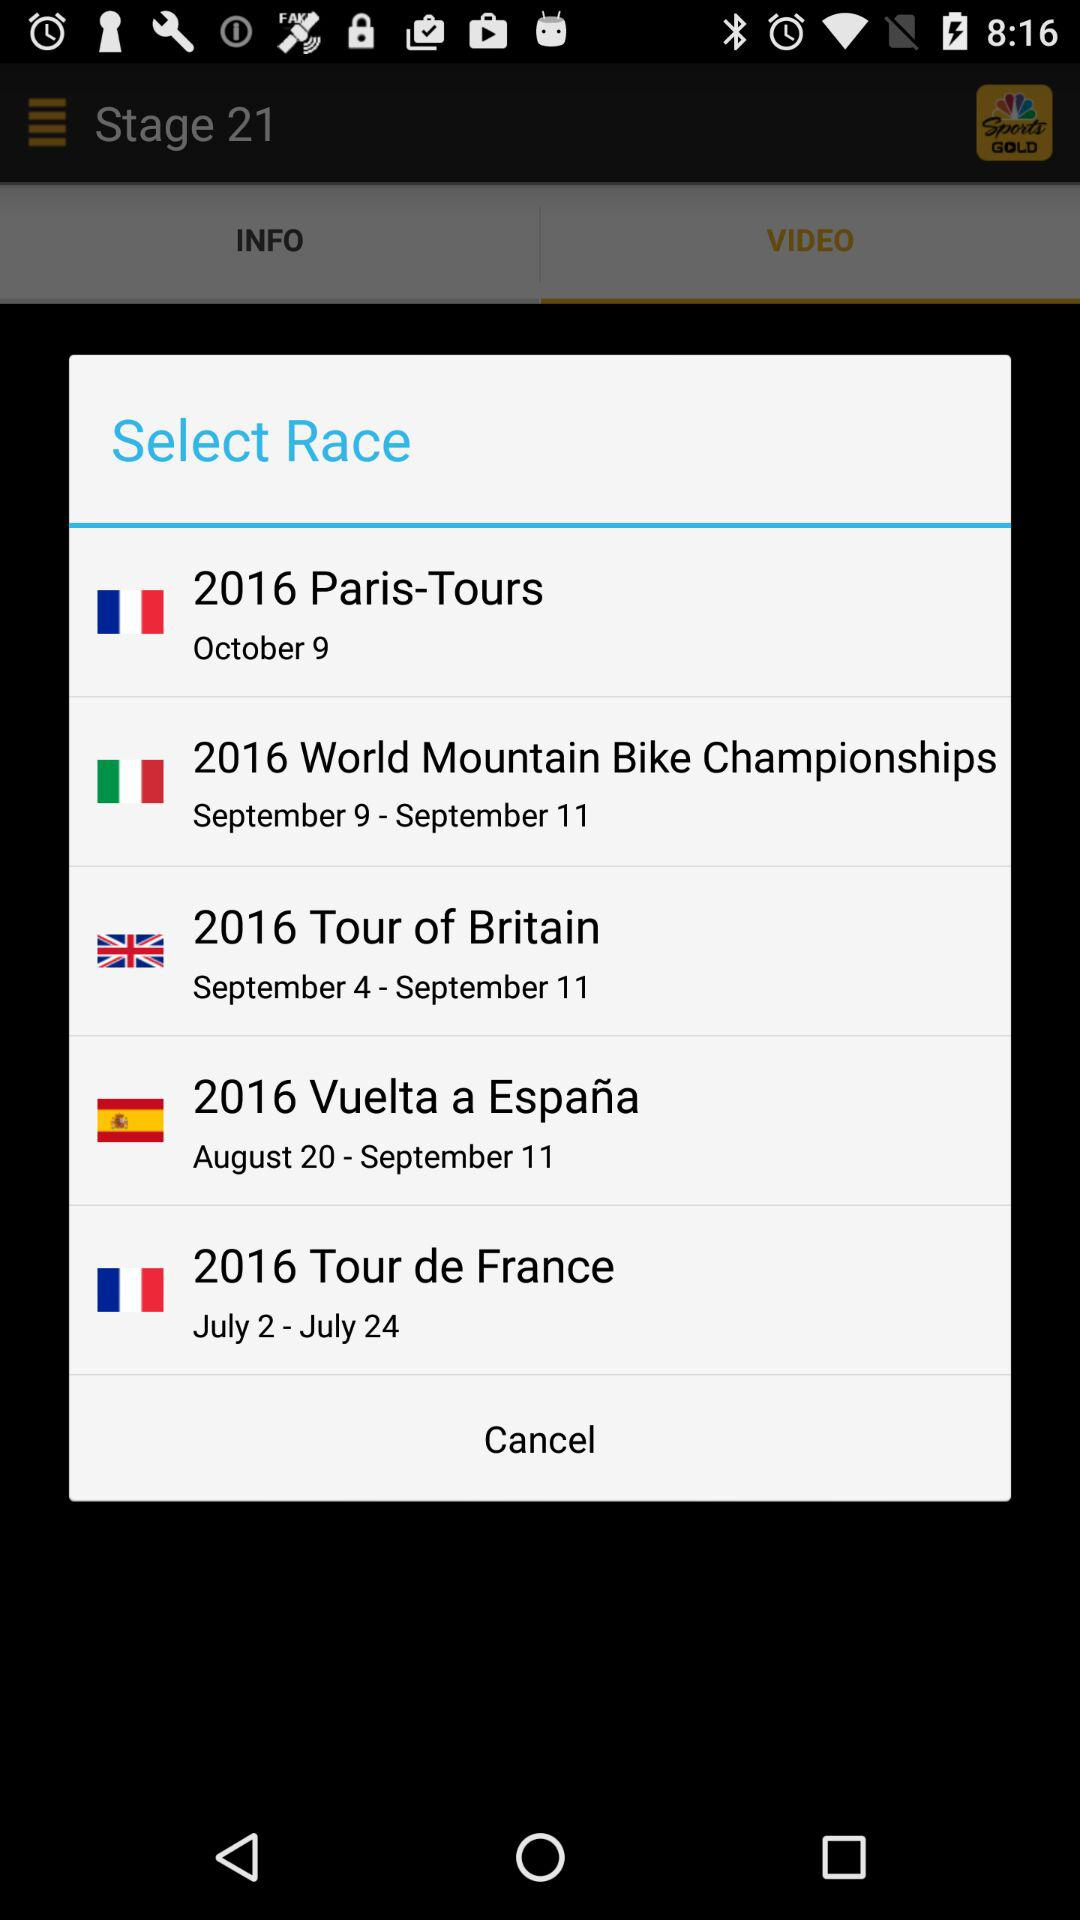Which tour will happen in the month of July? The tour that will happen in the month of July is the "2016 Tour de France". 